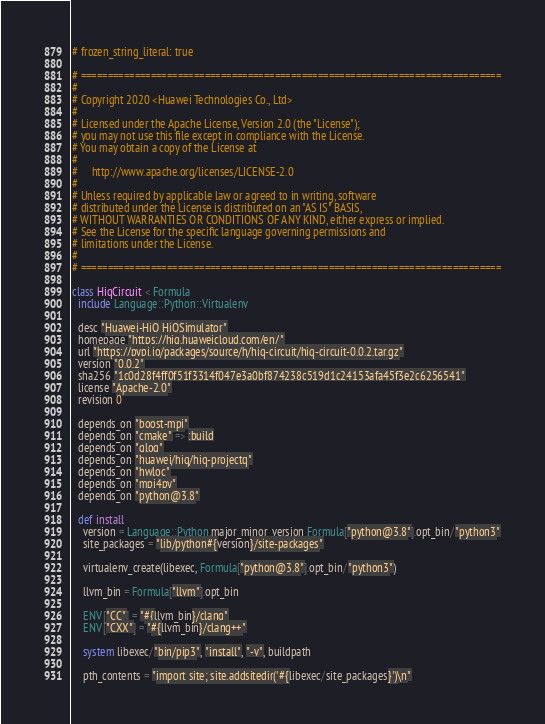Convert code to text. <code><loc_0><loc_0><loc_500><loc_500><_Ruby_># frozen_string_literal: true

# ==============================================================================
#
# Copyright 2020 <Huawei Technologies Co., Ltd>
#
# Licensed under the Apache License, Version 2.0 (the "License");
# you may not use this file except in compliance with the License.
# You may obtain a copy of the License at
#
#     http://www.apache.org/licenses/LICENSE-2.0
#
# Unless required by applicable law or agreed to in writing, software
# distributed under the License is distributed on an "AS IS" BASIS,
# WITHOUT WARRANTIES OR CONDITIONS OF ANY KIND, either express or implied.
# See the License for the specific language governing permissions and
# limitations under the License.
#
# ==============================================================================

class HiqCircuit < Formula
  include Language::Python::Virtualenv

  desc "Huawei-HiQ HiQSimulator"
  homepage "https://hiq.huaweicloud.com/en/"
  url "https://pypi.io/packages/source/h/hiq-circuit/hiq-circuit-0.0.2.tar.gz"
  version "0.0.2"
  sha256 "1c0d28f4ff0f51f3314f047e3a0bf874238c519d1c24153afa45f3e2c6256541"
  license "Apache-2.0"
  revision 0

  depends_on "boost-mpi"
  depends_on "cmake" => :build
  depends_on "glog"
  depends_on "huawei/hiq/hiq-projectq"
  depends_on "hwloc"
  depends_on "mpi4py"
  depends_on "python@3.8"

  def install
    version = Language::Python.major_minor_version Formula["python@3.8"].opt_bin/"python3"
    site_packages = "lib/python#{version}/site-packages"

    virtualenv_create(libexec, Formula["python@3.8"].opt_bin/"python3")

    llvm_bin = Formula["llvm"].opt_bin

    ENV["CC"] = "#{llvm_bin}/clang"
    ENV["CXX"] = "#{llvm_bin}/clang++"

    system libexec/"bin/pip3", "install", "-v", buildpath

    pth_contents = "import site; site.addsitedir('#{libexec/site_packages}')\n"</code> 